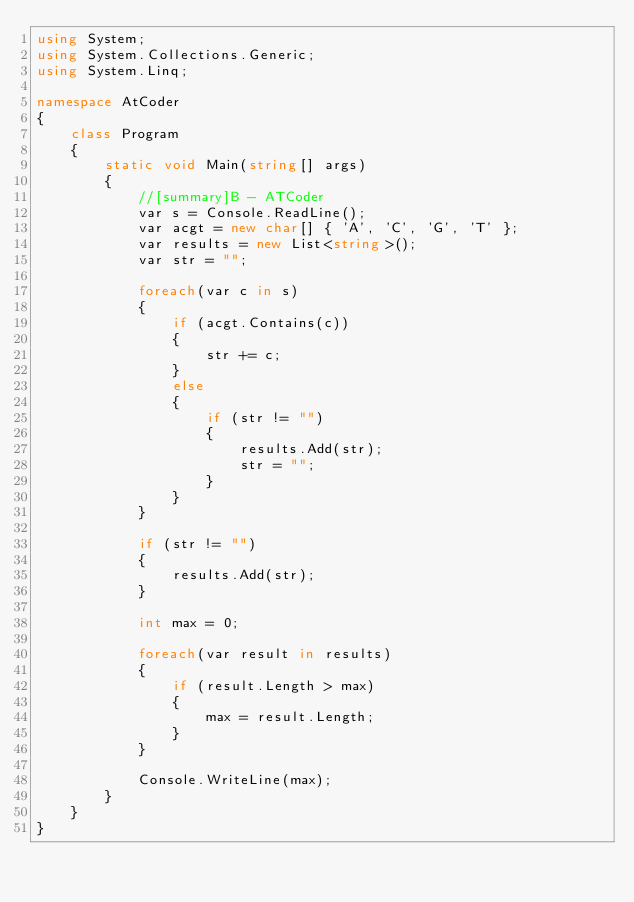<code> <loc_0><loc_0><loc_500><loc_500><_C#_>using System;
using System.Collections.Generic;
using System.Linq;

namespace AtCoder
{
    class Program
    {
        static void Main(string[] args)
        {
            //[summary]B - ATCoder
            var s = Console.ReadLine();
            var acgt = new char[] { 'A', 'C', 'G', 'T' };
            var results = new List<string>();
            var str = "";

            foreach(var c in s)
            {
                if (acgt.Contains(c))
                {
                    str += c;
                }
                else
                {
                    if (str != "")
                    {
                        results.Add(str);
                        str = "";
                    }
                }
            }

            if (str != "")
            {
                results.Add(str);
            }

            int max = 0;

            foreach(var result in results)
            {
                if (result.Length > max)
                {
                    max = result.Length;
                }
            }

            Console.WriteLine(max);
        }
    }
}</code> 